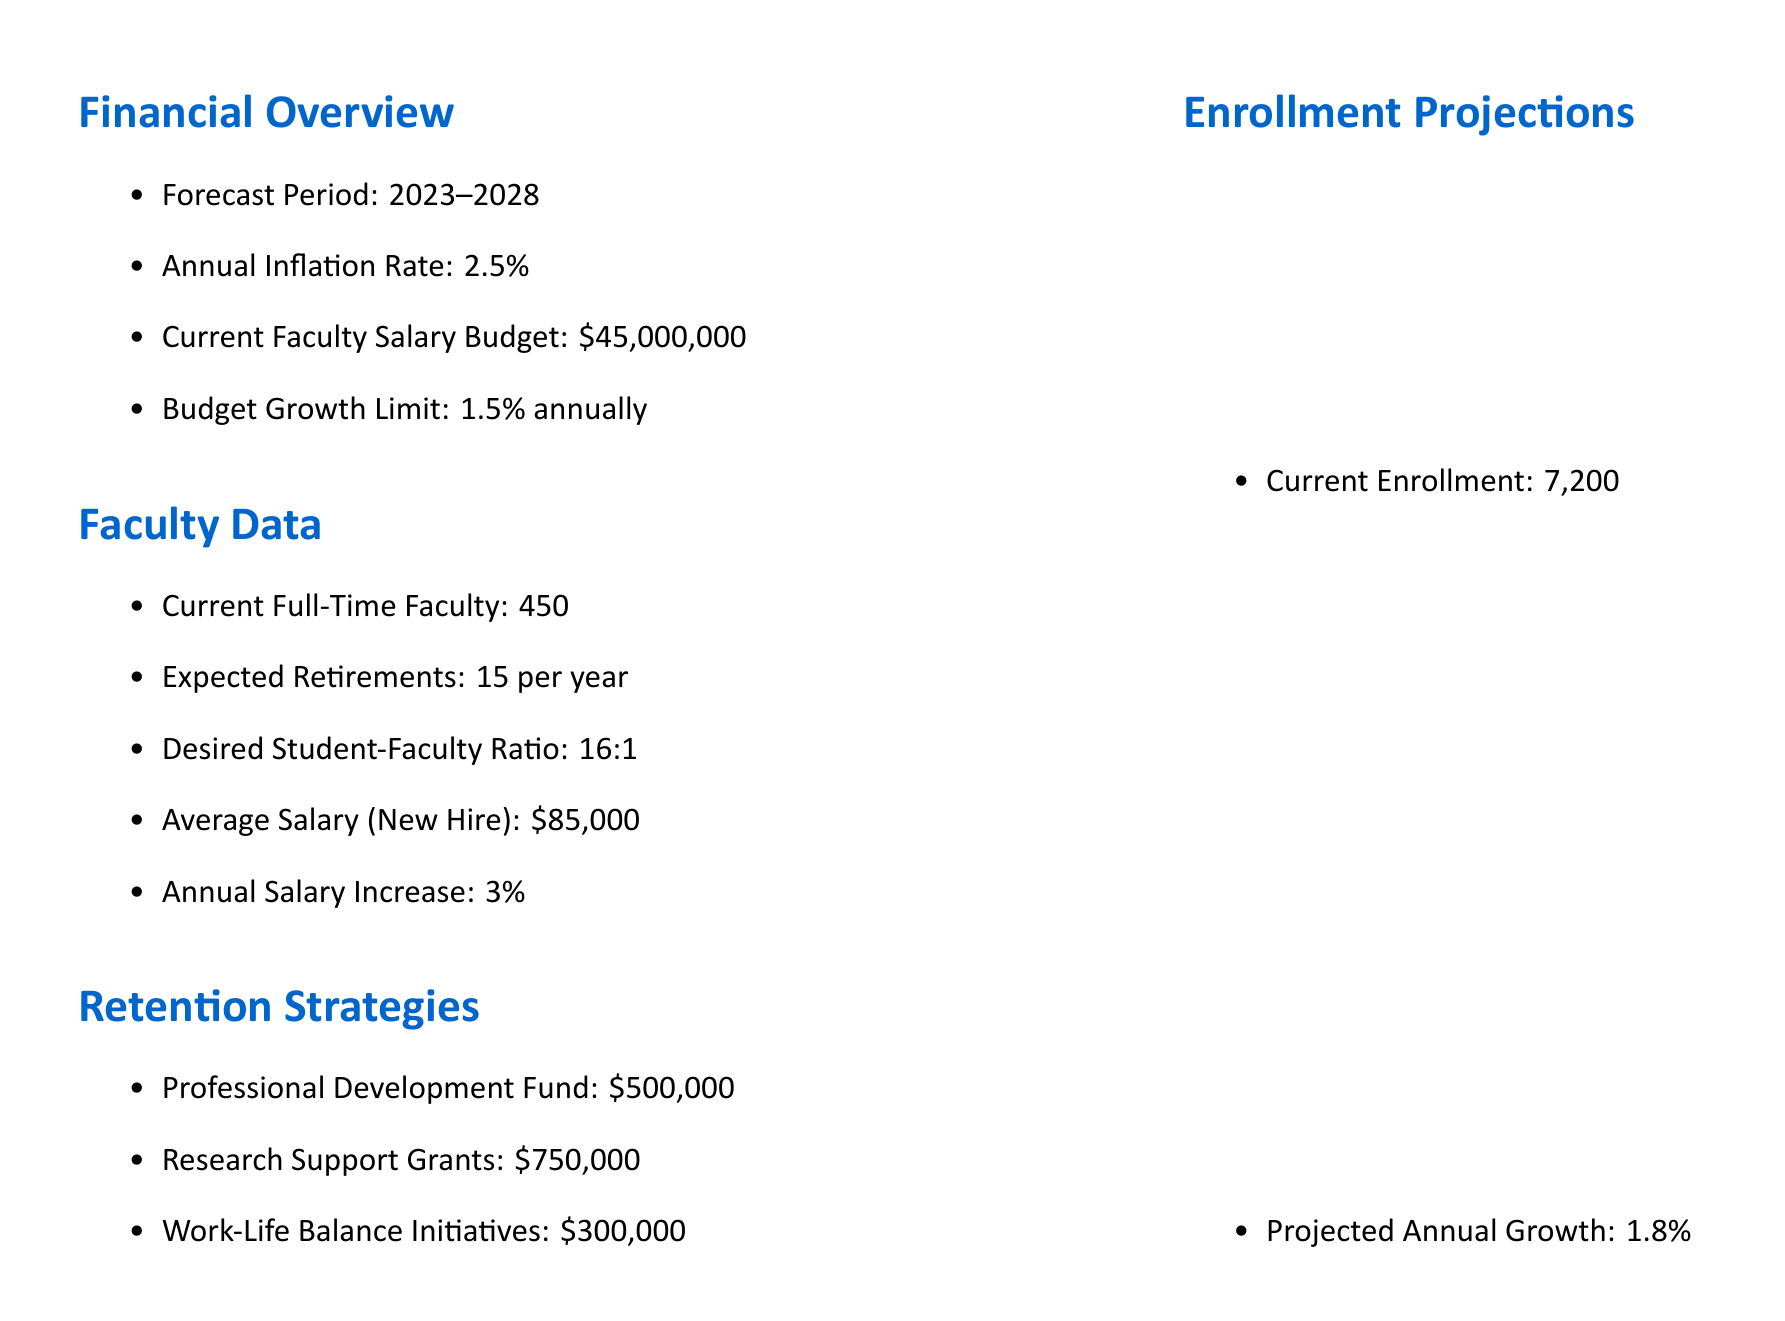What is the total faculty salary budget? The document states the current faculty salary budget is $45,000,000.
Answer: $45,000,000 What is the average salary for a new hire? According to the document, the average salary for a new hire is $85,000.
Answer: $85,000 How many new hires are projected each year? The forecast indicates that there will be 15 new hires each year.
Answer: 15 What is the projected annual growth rate for student enrollment? The document shows that the projected annual growth for student enrollment is 1.8%.
Answer: 1.8% What is the expected faculty retention rate? The document does not specify a faculty retention rate. The focus is on retention strategies, which include professional development and support.
Answer: Not specified How much is allocated for professional development? The document mentions a professional development fund of $500,000.
Answer: $500,000 What is the budget growth limit per year? The budget growth limit stated in the document is 1.5% annually.
Answer: 1.5% What is the desired student-faculty ratio? The document indicates the desired student-faculty ratio is 16:1.
Answer: 16:1 What is the expected change in state funding? The document states that state funding changes are expected to be a decrease of 2%.
Answer: -2% 